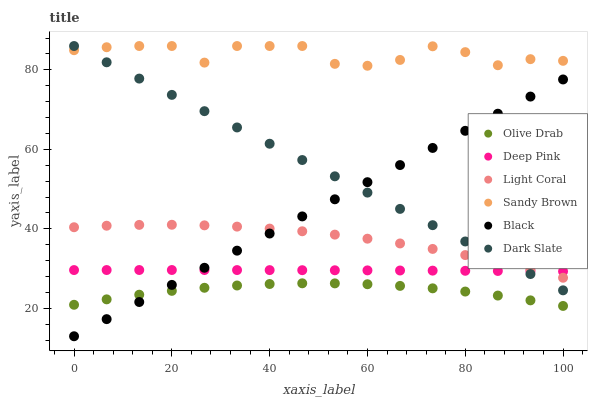Does Olive Drab have the minimum area under the curve?
Answer yes or no. Yes. Does Sandy Brown have the maximum area under the curve?
Answer yes or no. Yes. Does Light Coral have the minimum area under the curve?
Answer yes or no. No. Does Light Coral have the maximum area under the curve?
Answer yes or no. No. Is Dark Slate the smoothest?
Answer yes or no. Yes. Is Sandy Brown the roughest?
Answer yes or no. Yes. Is Light Coral the smoothest?
Answer yes or no. No. Is Light Coral the roughest?
Answer yes or no. No. Does Black have the lowest value?
Answer yes or no. Yes. Does Light Coral have the lowest value?
Answer yes or no. No. Does Sandy Brown have the highest value?
Answer yes or no. Yes. Does Light Coral have the highest value?
Answer yes or no. No. Is Olive Drab less than Deep Pink?
Answer yes or no. Yes. Is Deep Pink greater than Olive Drab?
Answer yes or no. Yes. Does Light Coral intersect Black?
Answer yes or no. Yes. Is Light Coral less than Black?
Answer yes or no. No. Is Light Coral greater than Black?
Answer yes or no. No. Does Olive Drab intersect Deep Pink?
Answer yes or no. No. 